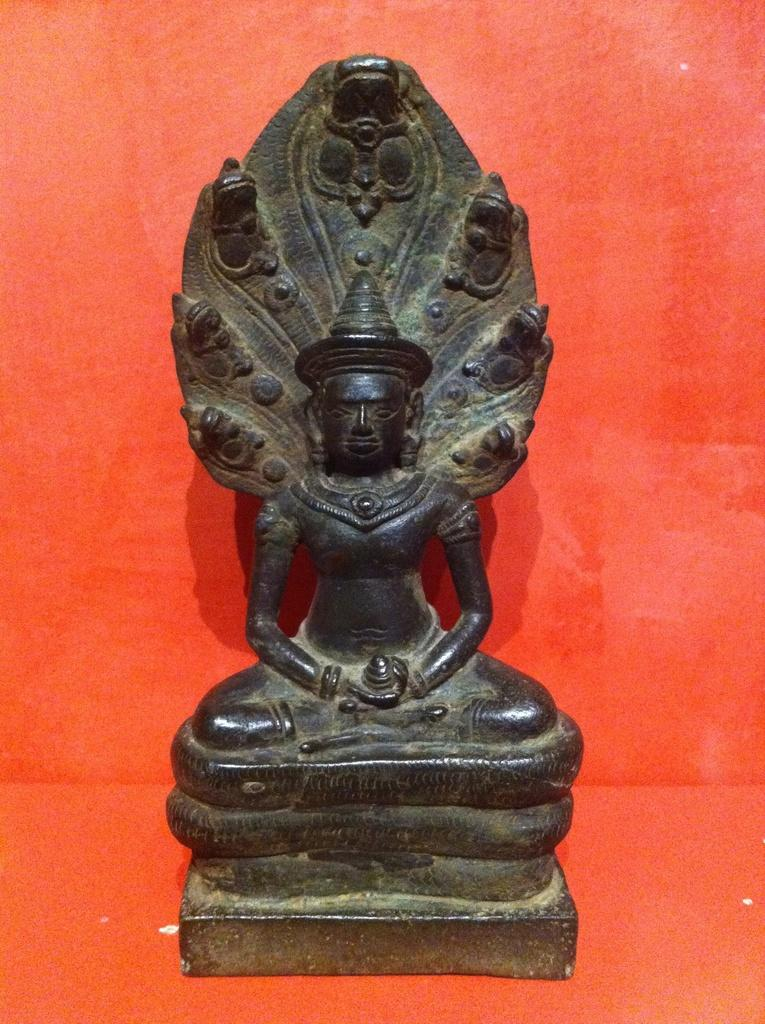What is one of the main features in the image? There is a wall in the image. Can you describe any objects or figures on the wall? There is a black color statue on the wall. What type of string is being used to hold the statue in place in the image? There is no string visible in the image, and the statue appears to be standing on its own. 